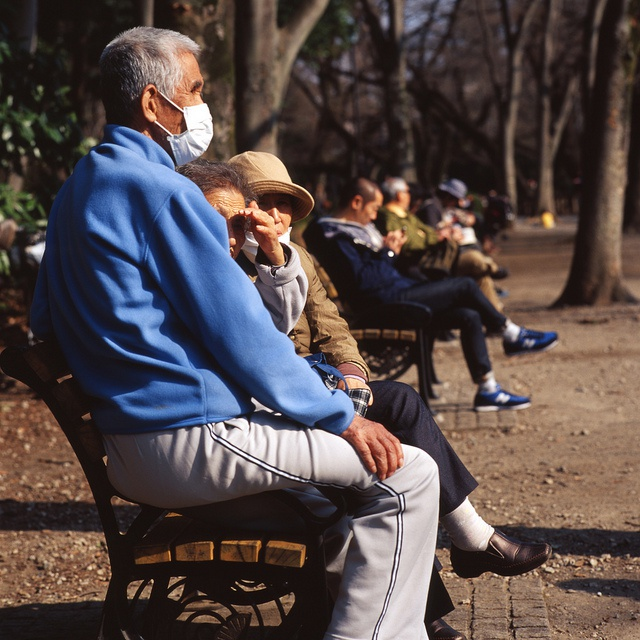Describe the objects in this image and their specific colors. I can see people in black, lightgray, navy, and gray tones, bench in black, maroon, brown, and gray tones, people in black, gray, maroon, and tan tones, people in black, navy, gray, and darkgray tones, and people in black, gray, maroon, and lightgray tones in this image. 